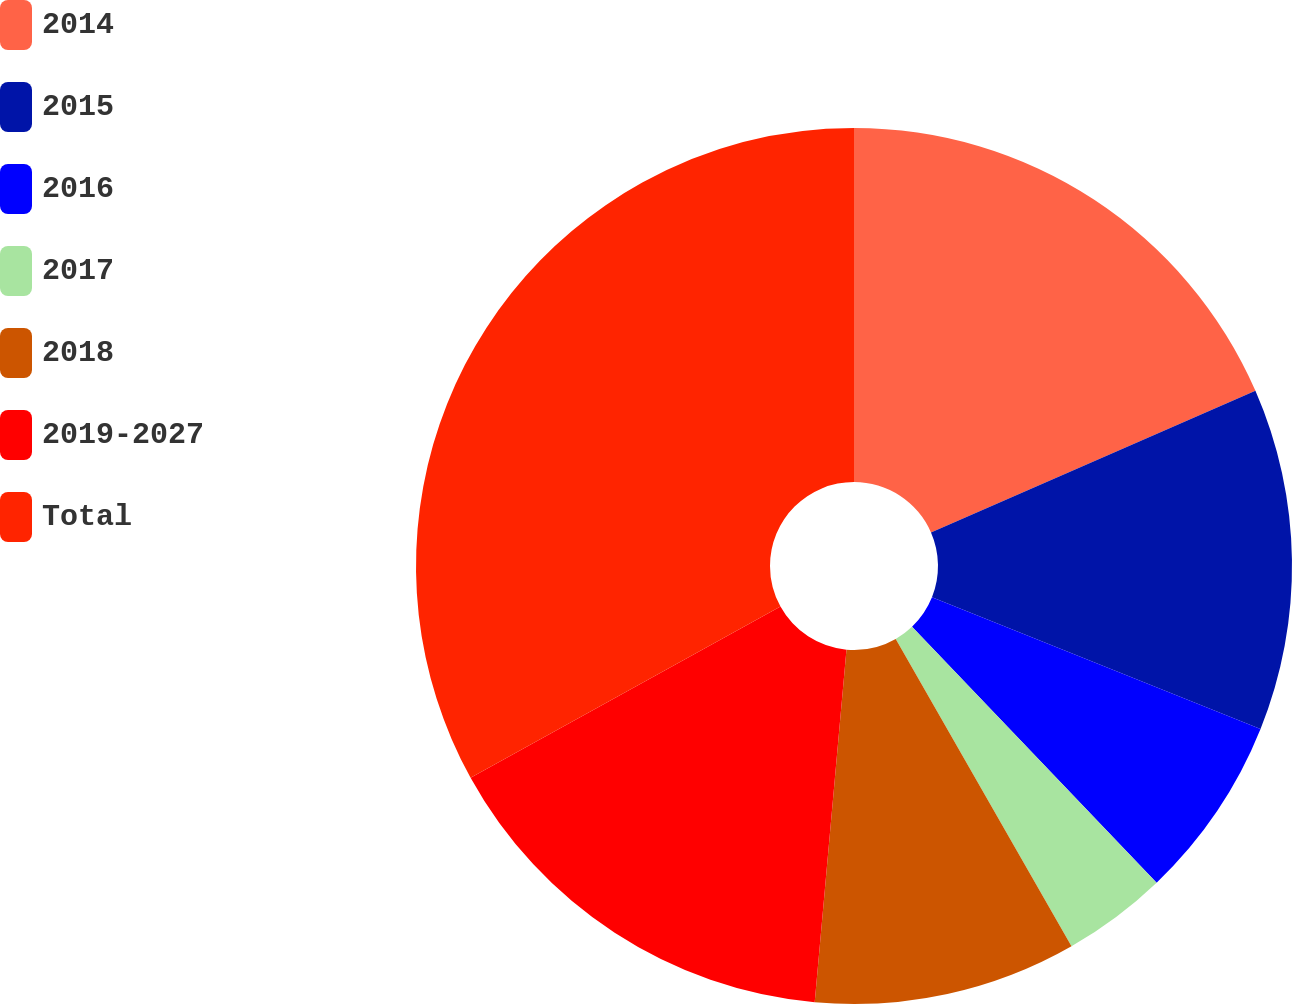<chart> <loc_0><loc_0><loc_500><loc_500><pie_chart><fcel>2014<fcel>2015<fcel>2016<fcel>2017<fcel>2018<fcel>2019-2027<fcel>Total<nl><fcel>18.45%<fcel>12.62%<fcel>6.79%<fcel>3.87%<fcel>9.7%<fcel>15.54%<fcel>33.03%<nl></chart> 